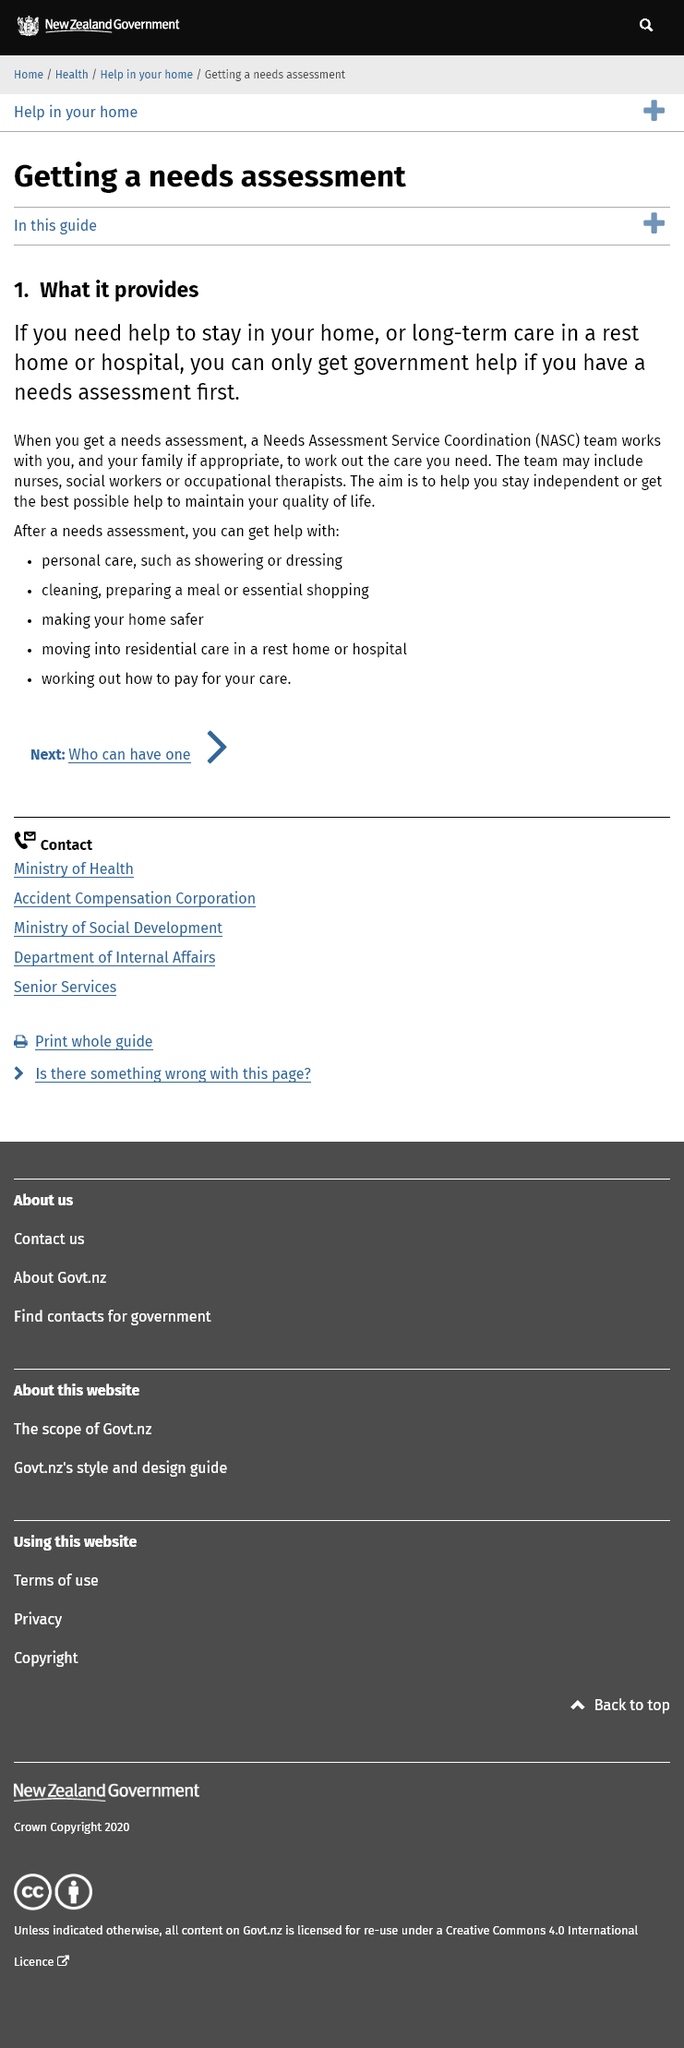Outline some significant characteristics in this image. It is possible to obtain assistance in making one's home safer following a needs assessment. The NASC team may include nurses, social workers, and occupational therapists. NASC stands for Needs Assessment Service Coordination, which involves the assessment of needs and the coordination of services to meet those needs. 